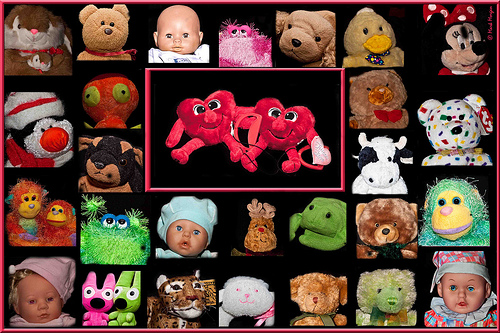<image>
Is the baby under the monkey? Yes. The baby is positioned underneath the monkey, with the monkey above it in the vertical space. 